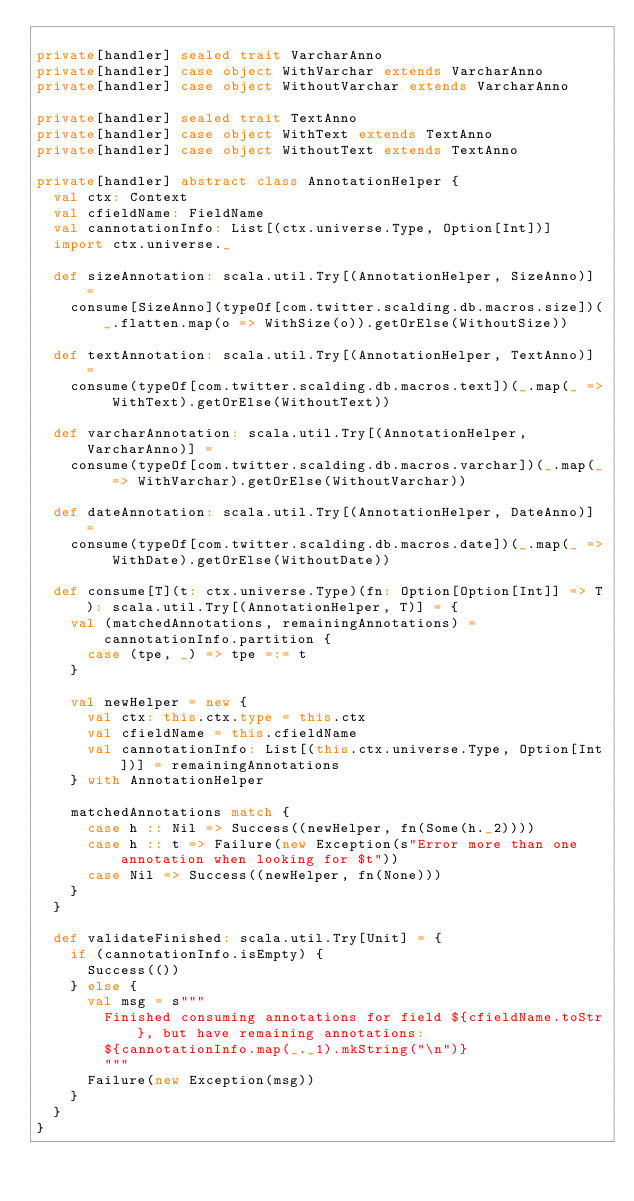Convert code to text. <code><loc_0><loc_0><loc_500><loc_500><_Scala_>
private[handler] sealed trait VarcharAnno
private[handler] case object WithVarchar extends VarcharAnno
private[handler] case object WithoutVarchar extends VarcharAnno

private[handler] sealed trait TextAnno
private[handler] case object WithText extends TextAnno
private[handler] case object WithoutText extends TextAnno

private[handler] abstract class AnnotationHelper {
  val ctx: Context
  val cfieldName: FieldName
  val cannotationInfo: List[(ctx.universe.Type, Option[Int])]
  import ctx.universe._

  def sizeAnnotation: scala.util.Try[(AnnotationHelper, SizeAnno)] =
    consume[SizeAnno](typeOf[com.twitter.scalding.db.macros.size])(_.flatten.map(o => WithSize(o)).getOrElse(WithoutSize))

  def textAnnotation: scala.util.Try[(AnnotationHelper, TextAnno)] =
    consume(typeOf[com.twitter.scalding.db.macros.text])(_.map(_ => WithText).getOrElse(WithoutText))

  def varcharAnnotation: scala.util.Try[(AnnotationHelper, VarcharAnno)] =
    consume(typeOf[com.twitter.scalding.db.macros.varchar])(_.map(_ => WithVarchar).getOrElse(WithoutVarchar))

  def dateAnnotation: scala.util.Try[(AnnotationHelper, DateAnno)] =
    consume(typeOf[com.twitter.scalding.db.macros.date])(_.map(_ => WithDate).getOrElse(WithoutDate))

  def consume[T](t: ctx.universe.Type)(fn: Option[Option[Int]] => T): scala.util.Try[(AnnotationHelper, T)] = {
    val (matchedAnnotations, remainingAnnotations) = cannotationInfo.partition {
      case (tpe, _) => tpe =:= t
    }

    val newHelper = new {
      val ctx: this.ctx.type = this.ctx
      val cfieldName = this.cfieldName
      val cannotationInfo: List[(this.ctx.universe.Type, Option[Int])] = remainingAnnotations
    } with AnnotationHelper

    matchedAnnotations match {
      case h :: Nil => Success((newHelper, fn(Some(h._2))))
      case h :: t => Failure(new Exception(s"Error more than one annotation when looking for $t"))
      case Nil => Success((newHelper, fn(None)))
    }
  }

  def validateFinished: scala.util.Try[Unit] = {
    if (cannotationInfo.isEmpty) {
      Success(())
    } else {
      val msg = s"""
        Finished consuming annotations for field ${cfieldName.toStr}, but have remaining annotations:
        ${cannotationInfo.map(_._1).mkString("\n")}
        """
      Failure(new Exception(msg))
    }
  }
}
</code> 